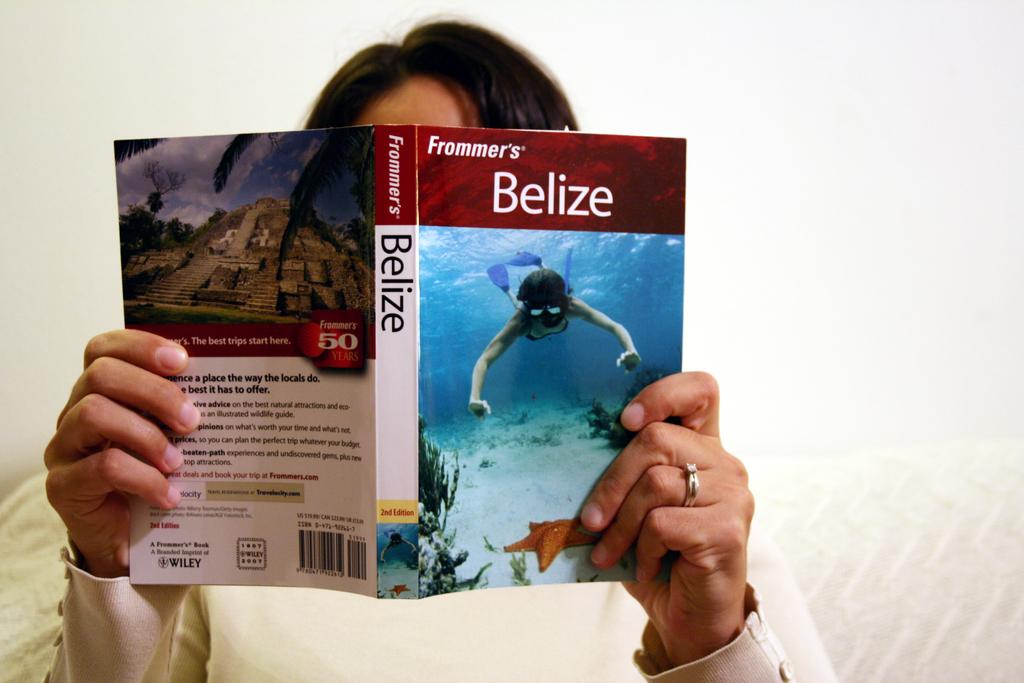<image>
Create a compact narrative representing the image presented. A person reading Frommer's Belize travel guide with a snorkeler on the cover 